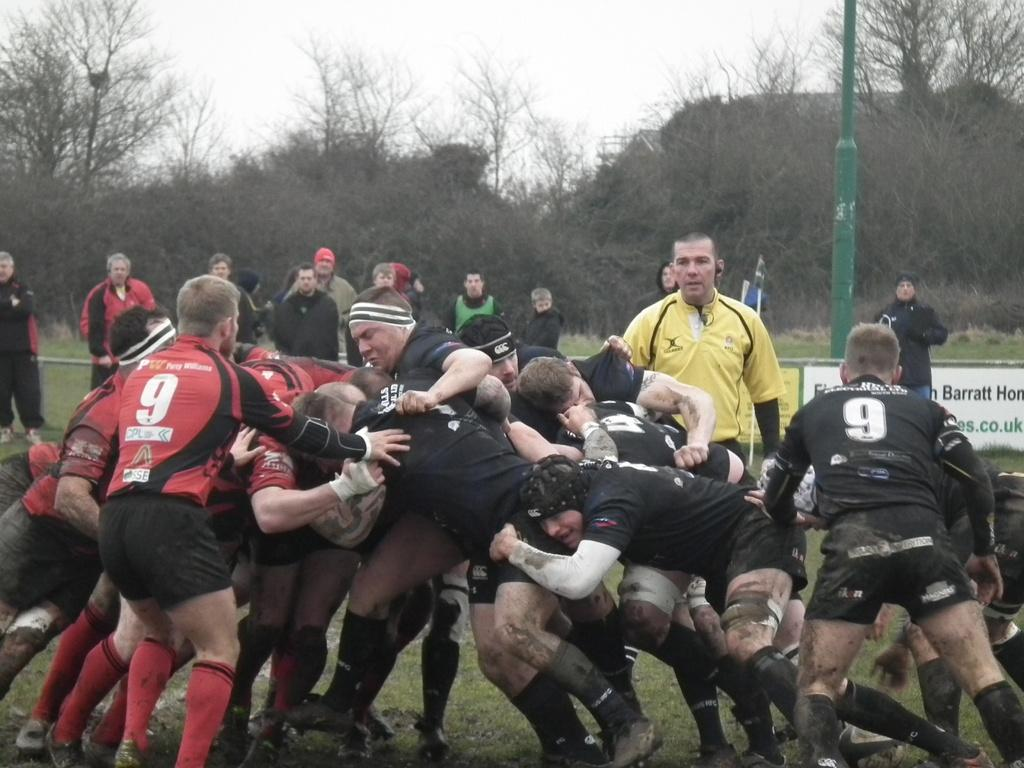What sport are the people playing in the image? The people are playing rugby in the image. Can you describe the gender of most of the players? Most of the players are men. What can be seen in the background of the image? There are trees and the sky visible in the background of the image. What type of crayon is being used to draw on the field during the rugby game? There is no crayon present in the image, and no one is drawing on the field during the rugby game. 